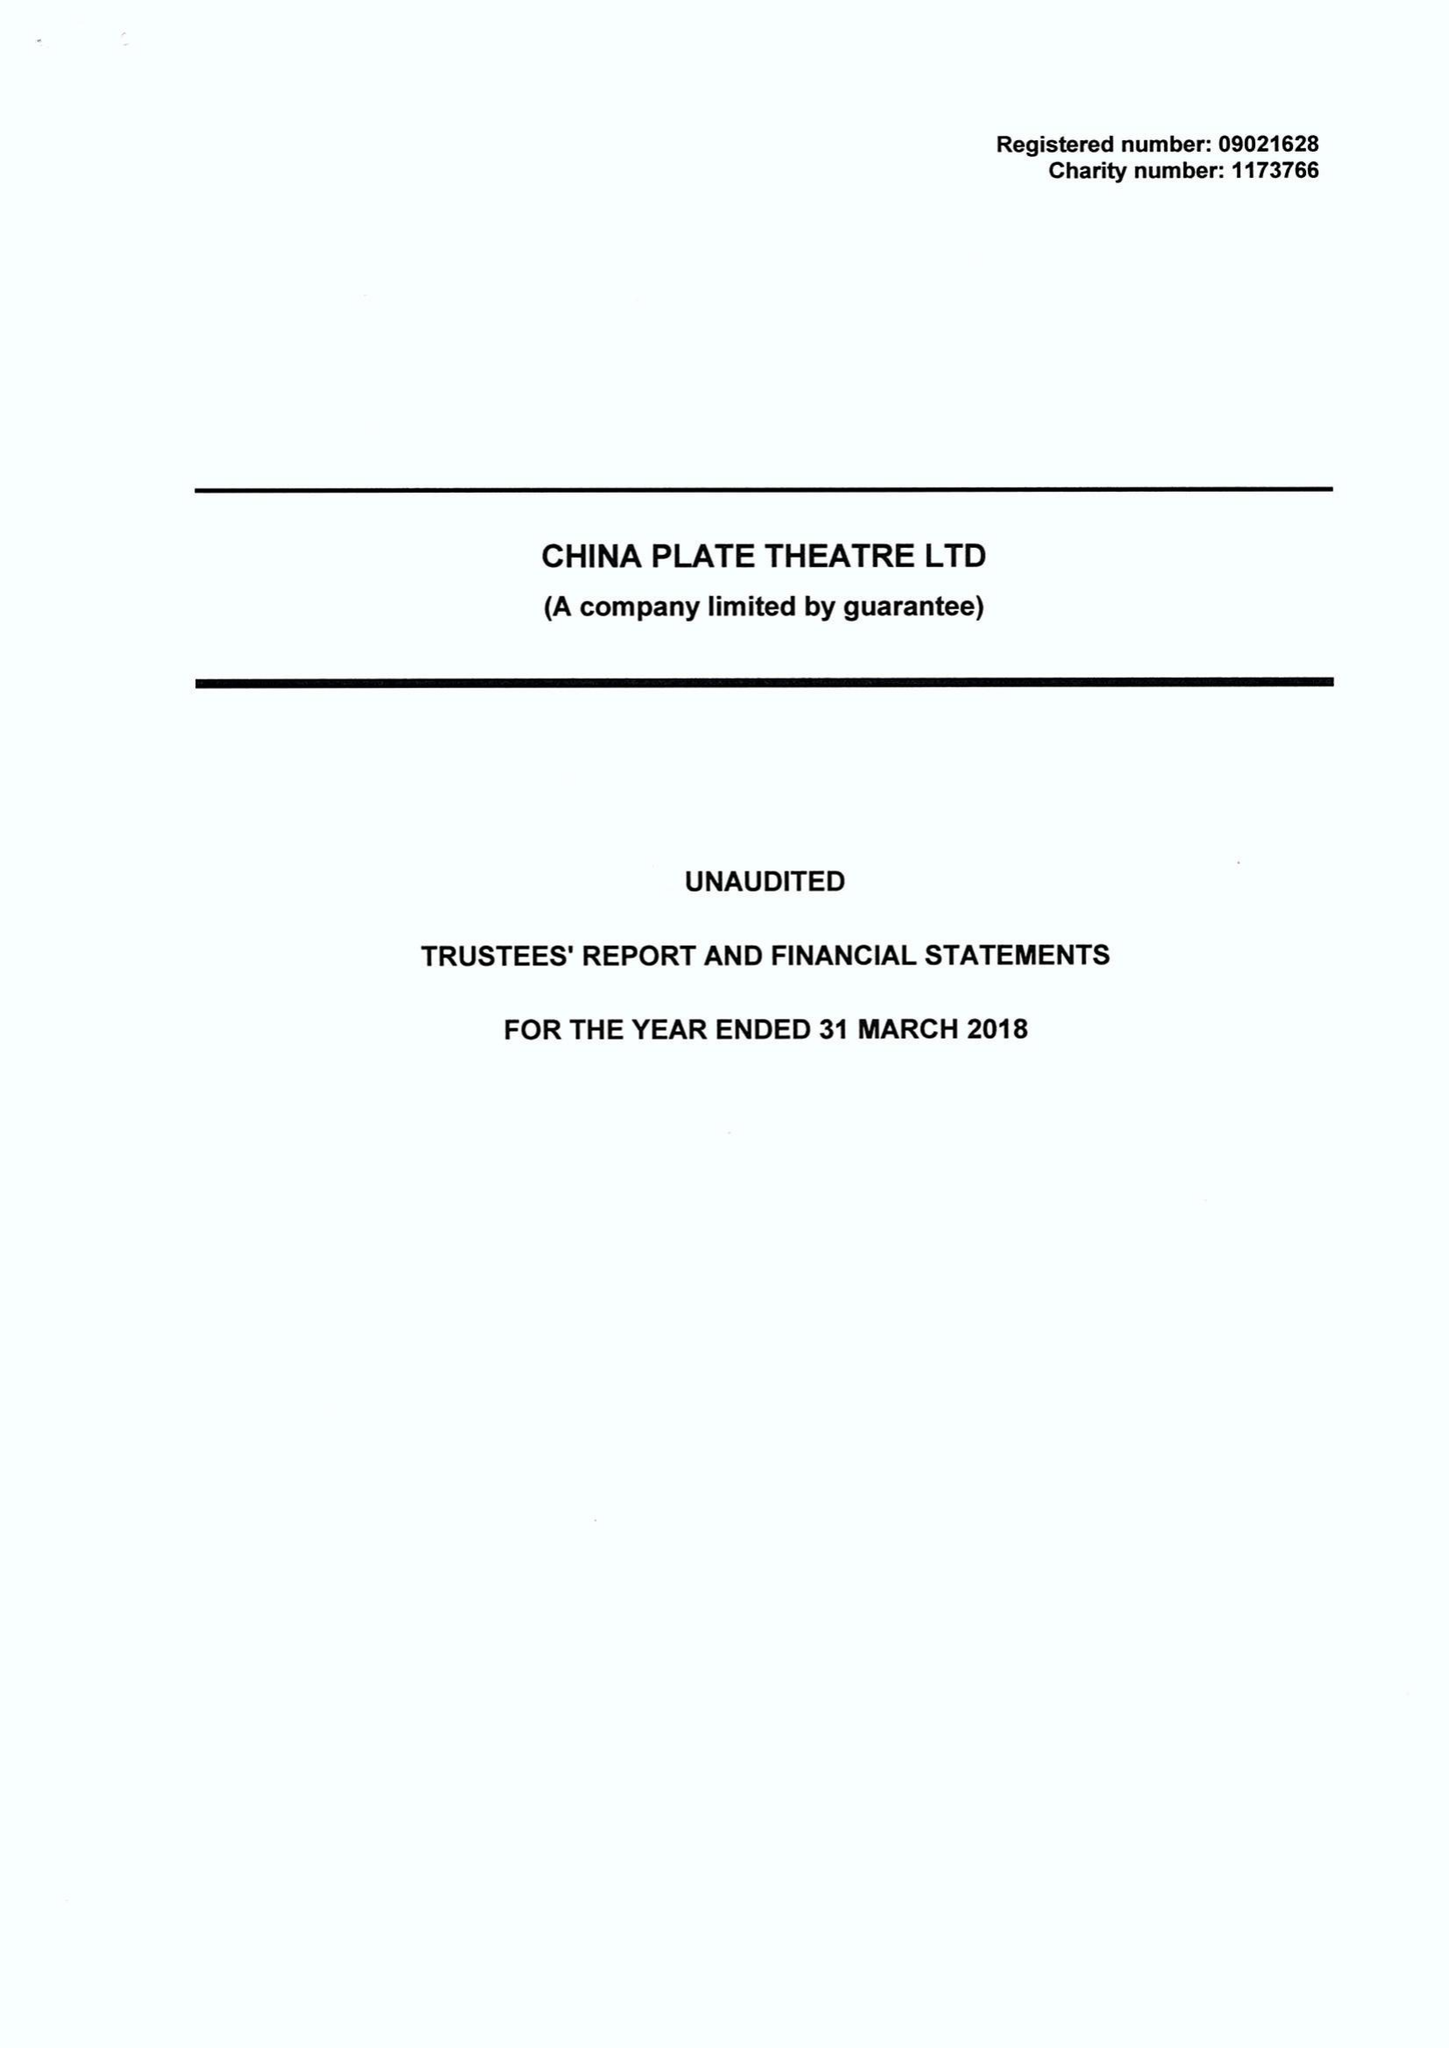What is the value for the charity_number?
Answer the question using a single word or phrase. 1173766 